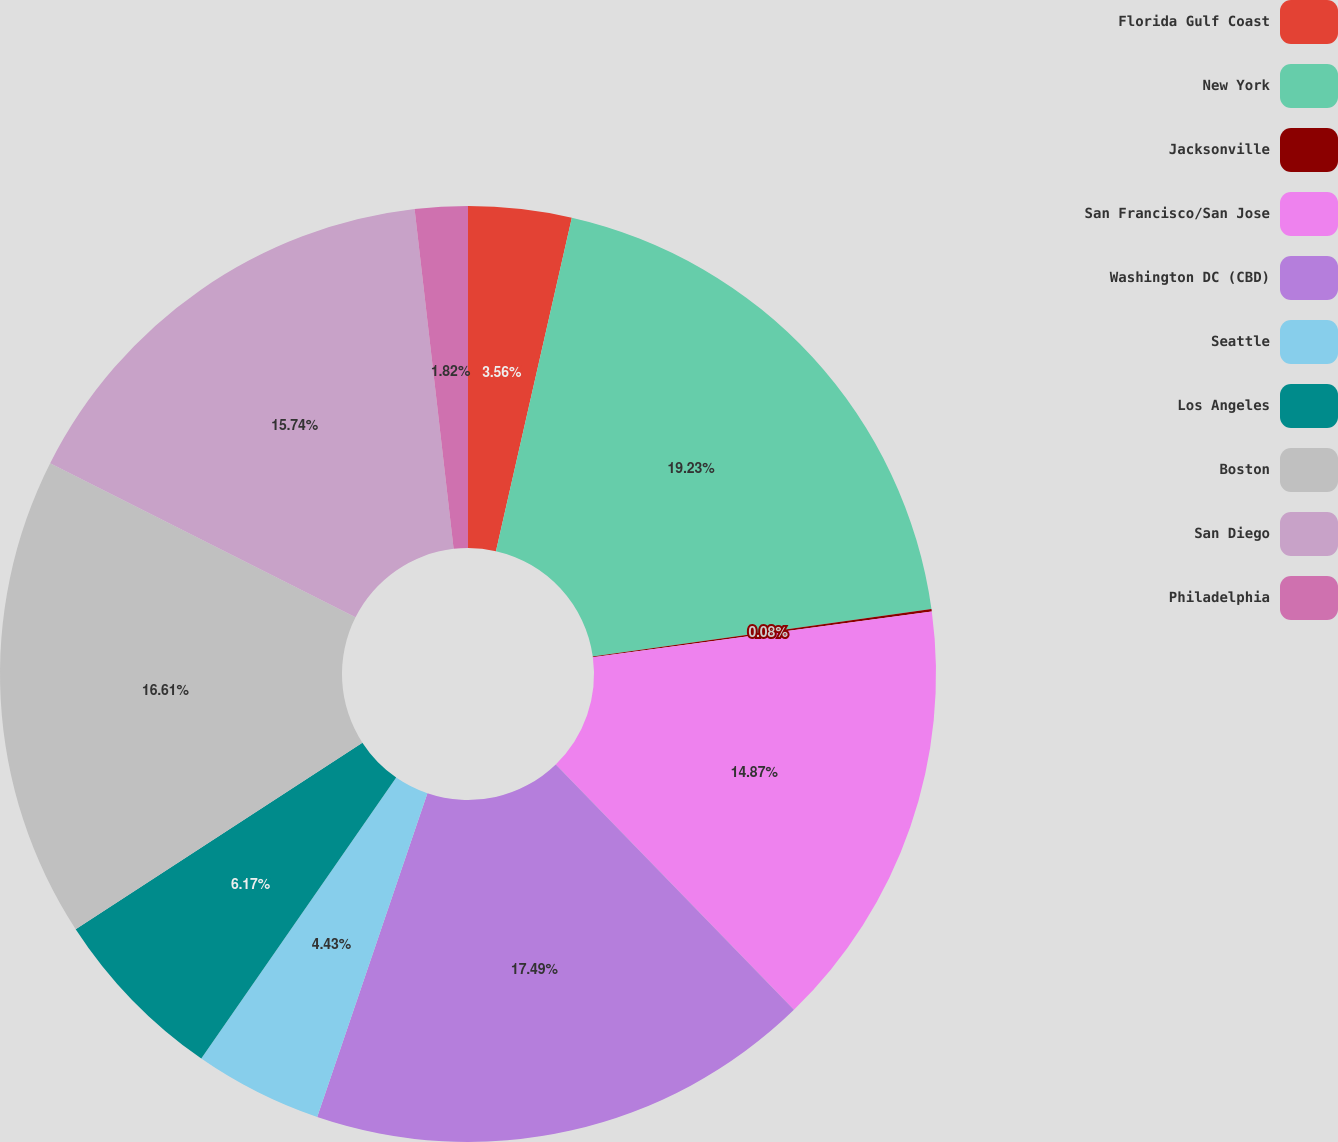<chart> <loc_0><loc_0><loc_500><loc_500><pie_chart><fcel>Florida Gulf Coast<fcel>New York<fcel>Jacksonville<fcel>San Francisco/San Jose<fcel>Washington DC (CBD)<fcel>Seattle<fcel>Los Angeles<fcel>Boston<fcel>San Diego<fcel>Philadelphia<nl><fcel>3.56%<fcel>19.22%<fcel>0.08%<fcel>14.87%<fcel>17.48%<fcel>4.43%<fcel>6.17%<fcel>16.61%<fcel>15.74%<fcel>1.82%<nl></chart> 